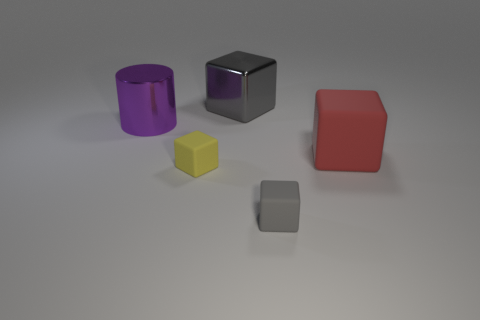What number of objects are small yellow matte objects or small cubes that are to the left of the gray metal thing?
Give a very brief answer. 1. What color is the large cylinder?
Offer a terse response. Purple. There is a matte thing that is on the left side of the small gray thing; what color is it?
Your answer should be very brief. Yellow. There is a rubber cube that is in front of the small yellow matte block; what number of purple metal cylinders are in front of it?
Provide a short and direct response. 0. There is a purple cylinder; is its size the same as the gray cube that is right of the big gray cube?
Your answer should be very brief. No. Are there any purple metallic objects that have the same size as the red cube?
Offer a terse response. Yes. How many things are either big purple metal cylinders or tiny red rubber balls?
Keep it short and to the point. 1. There is a gray object that is in front of the big red block; is its size the same as the rubber block that is on the left side of the tiny gray cube?
Your answer should be very brief. Yes. Is there a big gray object of the same shape as the yellow object?
Give a very brief answer. Yes. Are there fewer big cubes on the right side of the red thing than big cyan metal spheres?
Keep it short and to the point. No. 